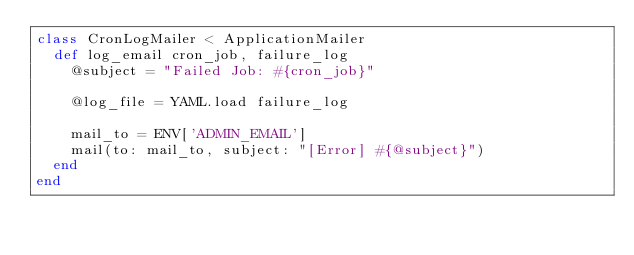Convert code to text. <code><loc_0><loc_0><loc_500><loc_500><_Ruby_>class CronLogMailer < ApplicationMailer
  def log_email cron_job, failure_log
    @subject = "Failed Job: #{cron_job}"

    @log_file = YAML.load failure_log

    mail_to = ENV['ADMIN_EMAIL']
    mail(to: mail_to, subject: "[Error] #{@subject}")
  end
end
</code> 